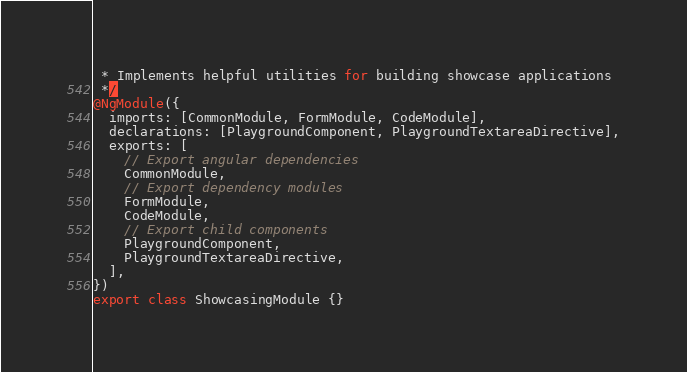Convert code to text. <code><loc_0><loc_0><loc_500><loc_500><_TypeScript_> * Implements helpful utilities for building showcase applications
 */
@NgModule({
  imports: [CommonModule, FormModule, CodeModule],
  declarations: [PlaygroundComponent, PlaygroundTextareaDirective],
  exports: [
    // Export angular dependencies
    CommonModule,
    // Export dependency modules
    FormModule,
    CodeModule,
    // Export child components
    PlaygroundComponent,
    PlaygroundTextareaDirective,
  ],
})
export class ShowcasingModule {}
</code> 